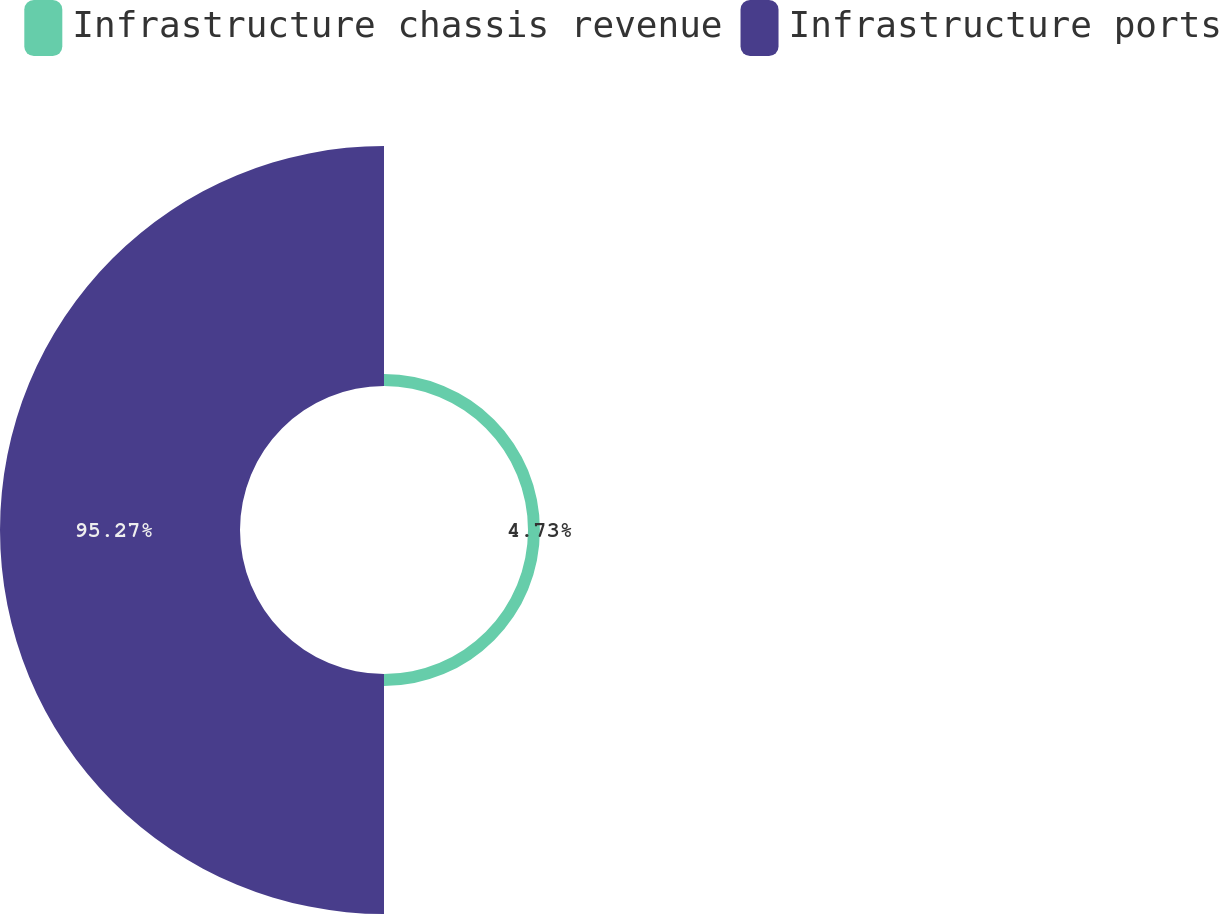Convert chart. <chart><loc_0><loc_0><loc_500><loc_500><pie_chart><fcel>Infrastructure chassis revenue<fcel>Infrastructure ports<nl><fcel>4.73%<fcel>95.27%<nl></chart> 